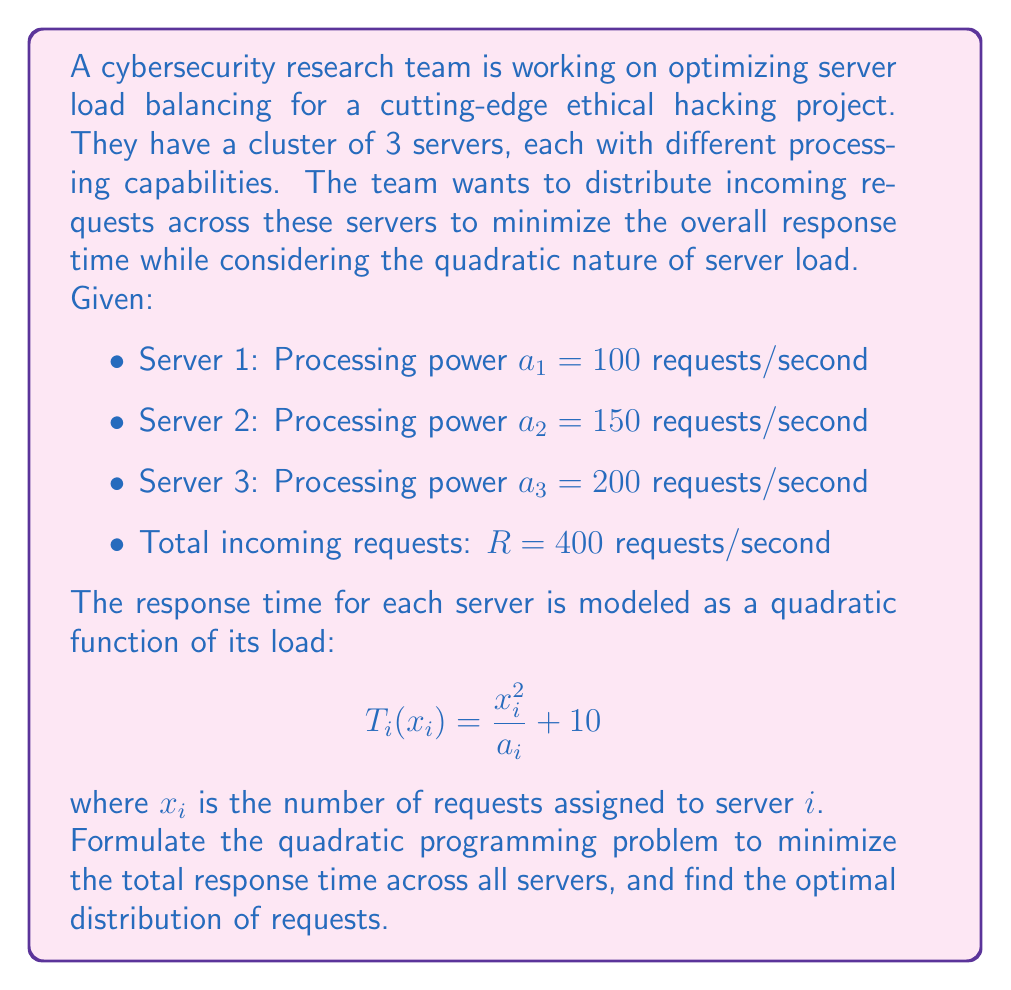Solve this math problem. To solve this server load balancing problem using quadratic programming, we need to follow these steps:

1. Define the objective function:
The total response time is the sum of individual server response times:
$$T_{total} = T_1(x_1) + T_2(x_2) + T_3(x_3)$$
$$T_{total} = (\frac{x_1^2}{a_1} + 10) + (\frac{x_2^2}{a_2} + 10) + (\frac{x_3^2}{a_3} + 10)$$
$$T_{total} = \frac{x_1^2}{100} + \frac{x_2^2}{150} + \frac{x_3^2}{200} + 30$$

2. Define the constraints:
   a. Non-negativity: $x_1, x_2, x_3 \geq 0$
   b. Total requests: $x_1 + x_2 + x_3 = 400$

3. Formulate the quadratic programming problem:
Minimize:
$$T_{total} = \frac{x_1^2}{100} + \frac{x_2^2}{150} + \frac{x_3^2}{200} + 30$$
Subject to:
$$x_1 + x_2 + x_3 = 400$$
$$x_1, x_2, x_3 \geq 0$$

4. Solve using the method of Lagrange multipliers:
Define the Lagrangian function:
$$L(x_1, x_2, x_3, \lambda) = \frac{x_1^2}{100} + \frac{x_2^2}{150} + \frac{x_3^2}{200} + 30 + \lambda(x_1 + x_2 + x_3 - 400)$$

5. Take partial derivatives and set them to zero:
$$\frac{\partial L}{\partial x_1} = \frac{2x_1}{100} + \lambda = 0$$
$$\frac{\partial L}{\partial x_2} = \frac{2x_2}{150} + \lambda = 0$$
$$\frac{\partial L}{\partial x_3} = \frac{2x_3}{200} + \lambda = 0$$
$$\frac{\partial L}{\partial \lambda} = x_1 + x_2 + x_3 - 400 = 0$$

6. Solve the system of equations:
From the first three equations:
$$x_1 = -50\lambda$$
$$x_2 = -75\lambda$$
$$x_3 = -100\lambda$$

Substituting into the fourth equation:
$$-50\lambda - 75\lambda - 100\lambda = -400$$
$$-225\lambda = -400$$
$$\lambda = \frac{400}{225} = \frac{16}{9}$$

7. Calculate the optimal distribution:
$$x_1 = -50 \cdot \frac{16}{9} = -\frac{800}{9} \approx 88.89$$
$$x_2 = -75 \cdot \frac{16}{9} = -\frac{1200}{9} \approx 133.33$$
$$x_3 = -100 \cdot \frac{16}{9} = -\frac{1600}{9} \approx 177.78$$

8. Verify the constraint:
$$88.89 + 133.33 + 177.78 = 400$$

The optimal distribution of requests is approximately:
Server 1: 89 requests/second
Server 2: 133 requests/second
Server 3: 178 requests/second
Answer: The optimal distribution of requests to minimize the total response time is:
Server 1: 89 requests/second
Server 2: 133 requests/second
Server 3: 178 requests/second 